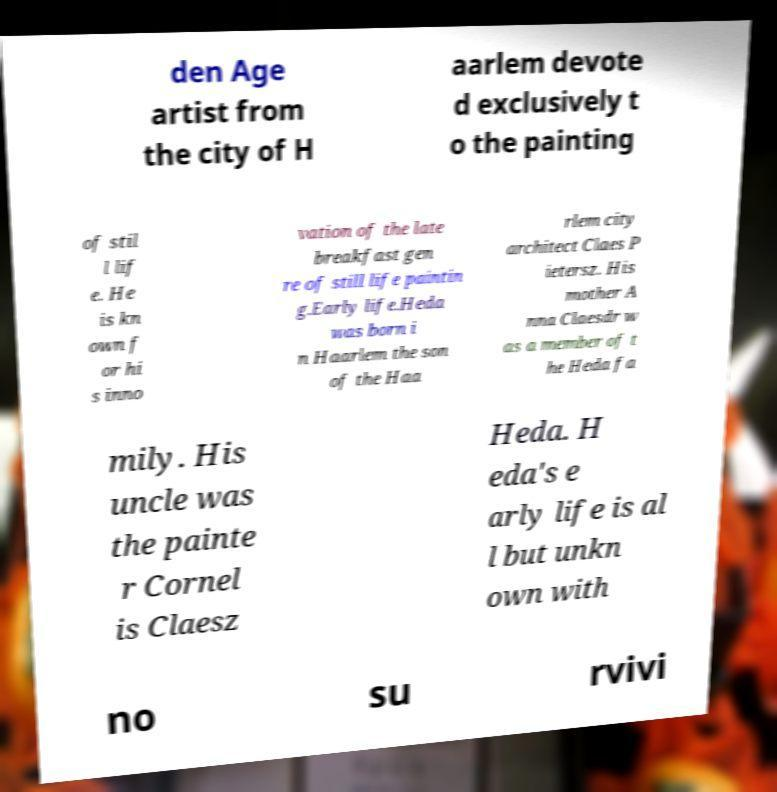Could you extract and type out the text from this image? den Age artist from the city of H aarlem devote d exclusively t o the painting of stil l lif e. He is kn own f or hi s inno vation of the late breakfast gen re of still life paintin g.Early life.Heda was born i n Haarlem the son of the Haa rlem city architect Claes P ietersz. His mother A nna Claesdr w as a member of t he Heda fa mily. His uncle was the painte r Cornel is Claesz Heda. H eda's e arly life is al l but unkn own with no su rvivi 